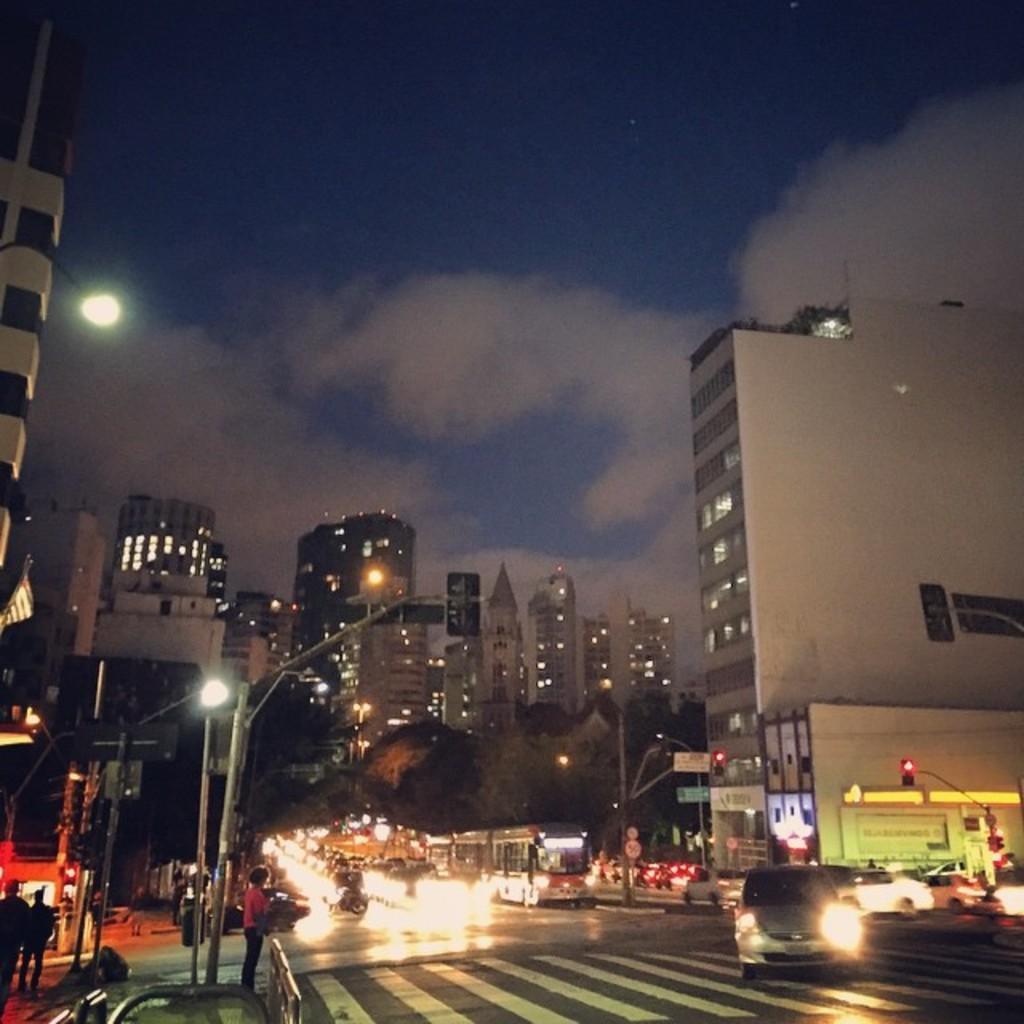In one or two sentences, can you explain what this image depicts? In this image we can see buildings, poles, trees, boards, lights, and people. There are vehicles on the road. In the background there is sky with clouds. 